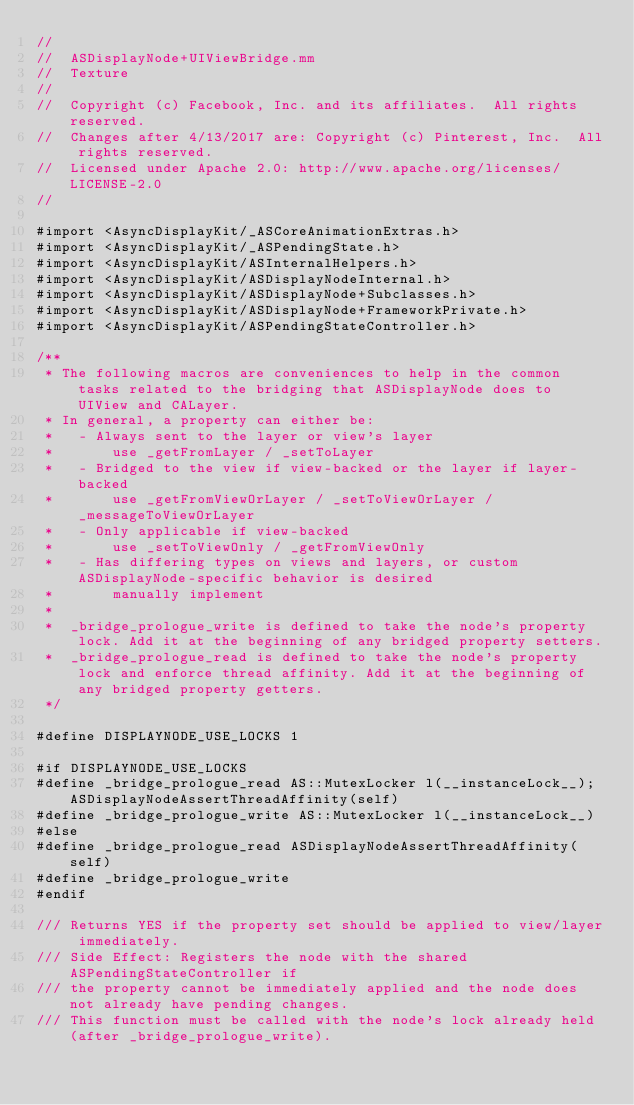<code> <loc_0><loc_0><loc_500><loc_500><_ObjectiveC_>//
//  ASDisplayNode+UIViewBridge.mm
//  Texture
//
//  Copyright (c) Facebook, Inc. and its affiliates.  All rights reserved.
//  Changes after 4/13/2017 are: Copyright (c) Pinterest, Inc.  All rights reserved.
//  Licensed under Apache 2.0: http://www.apache.org/licenses/LICENSE-2.0
//

#import <AsyncDisplayKit/_ASCoreAnimationExtras.h>
#import <AsyncDisplayKit/_ASPendingState.h>
#import <AsyncDisplayKit/ASInternalHelpers.h>
#import <AsyncDisplayKit/ASDisplayNodeInternal.h>
#import <AsyncDisplayKit/ASDisplayNode+Subclasses.h>
#import <AsyncDisplayKit/ASDisplayNode+FrameworkPrivate.h>
#import <AsyncDisplayKit/ASPendingStateController.h>

/**
 * The following macros are conveniences to help in the common tasks related to the bridging that ASDisplayNode does to UIView and CALayer.
 * In general, a property can either be:
 *   - Always sent to the layer or view's layer
 *       use _getFromLayer / _setToLayer
 *   - Bridged to the view if view-backed or the layer if layer-backed
 *       use _getFromViewOrLayer / _setToViewOrLayer / _messageToViewOrLayer
 *   - Only applicable if view-backed
 *       use _setToViewOnly / _getFromViewOnly
 *   - Has differing types on views and layers, or custom ASDisplayNode-specific behavior is desired
 *       manually implement
 *
 *  _bridge_prologue_write is defined to take the node's property lock. Add it at the beginning of any bridged property setters.
 *  _bridge_prologue_read is defined to take the node's property lock and enforce thread affinity. Add it at the beginning of any bridged property getters.
 */

#define DISPLAYNODE_USE_LOCKS 1

#if DISPLAYNODE_USE_LOCKS
#define _bridge_prologue_read AS::MutexLocker l(__instanceLock__); ASDisplayNodeAssertThreadAffinity(self)
#define _bridge_prologue_write AS::MutexLocker l(__instanceLock__)
#else
#define _bridge_prologue_read ASDisplayNodeAssertThreadAffinity(self)
#define _bridge_prologue_write
#endif

/// Returns YES if the property set should be applied to view/layer immediately.
/// Side Effect: Registers the node with the shared ASPendingStateController if
/// the property cannot be immediately applied and the node does not already have pending changes.
/// This function must be called with the node's lock already held (after _bridge_prologue_write).</code> 